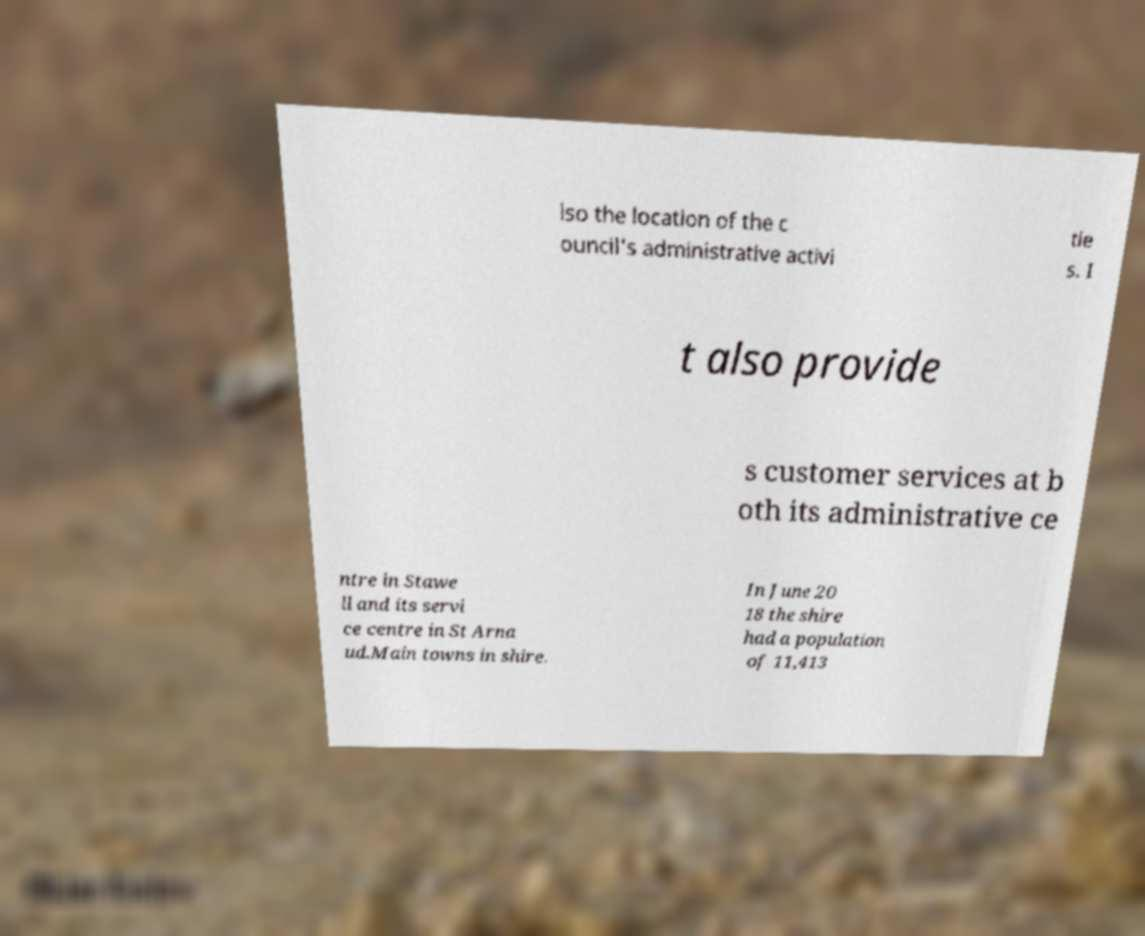Could you extract and type out the text from this image? lso the location of the c ouncil's administrative activi tie s. I t also provide s customer services at b oth its administrative ce ntre in Stawe ll and its servi ce centre in St Arna ud.Main towns in shire. In June 20 18 the shire had a population of 11,413 